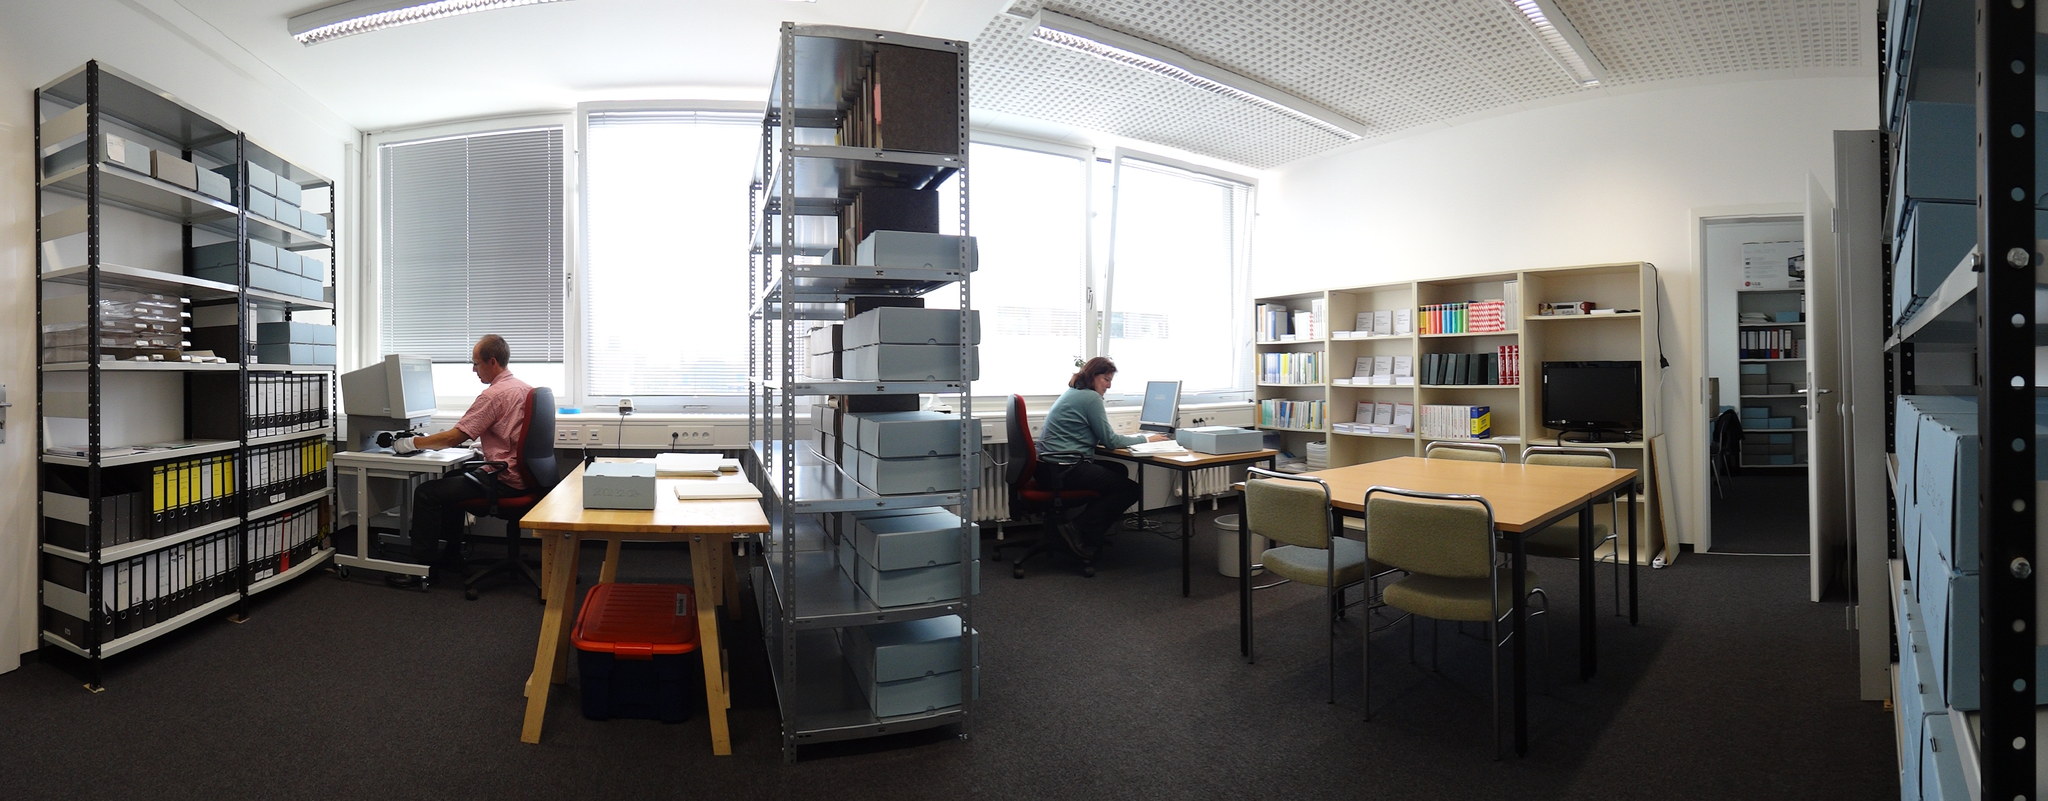How would you summarize this image in a sentence or two? In this image there is one person sitting at left side of this image and one more at right side of this image and there are some books racks, one in middle of this image and left side of this image and right side of this image as well and there are some tables and chairs are at bottom of this image. 